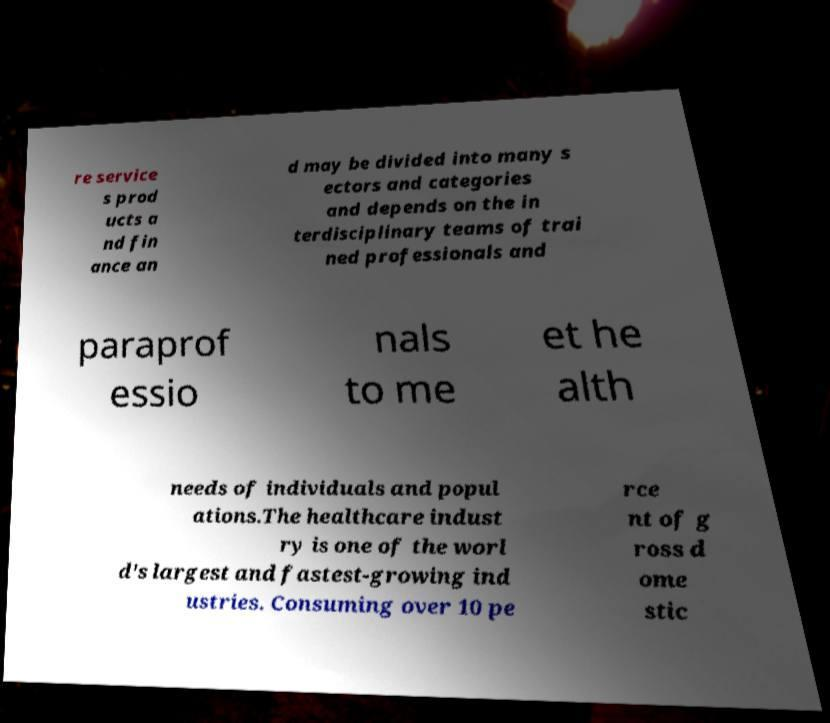Can you read and provide the text displayed in the image?This photo seems to have some interesting text. Can you extract and type it out for me? re service s prod ucts a nd fin ance an d may be divided into many s ectors and categories and depends on the in terdisciplinary teams of trai ned professionals and paraprof essio nals to me et he alth needs of individuals and popul ations.The healthcare indust ry is one of the worl d's largest and fastest-growing ind ustries. Consuming over 10 pe rce nt of g ross d ome stic 